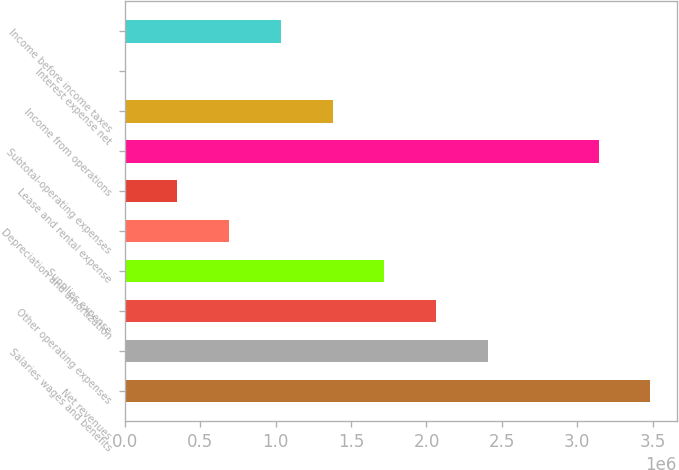Convert chart to OTSL. <chart><loc_0><loc_0><loc_500><loc_500><bar_chart><fcel>Net revenues<fcel>Salaries wages and benefits<fcel>Other operating expenses<fcel>Supplies expense<fcel>Depreciation and amortization<fcel>Lease and rental expense<fcel>Subtotal-operating expenses<fcel>Income from operations<fcel>Interest expense net<fcel>Income before income taxes<nl><fcel>3.48528e+06<fcel>2.40795e+06<fcel>2.06464e+06<fcel>1.72134e+06<fcel>691425<fcel>348120<fcel>3.14198e+06<fcel>1.37803e+06<fcel>4815<fcel>1.03473e+06<nl></chart> 